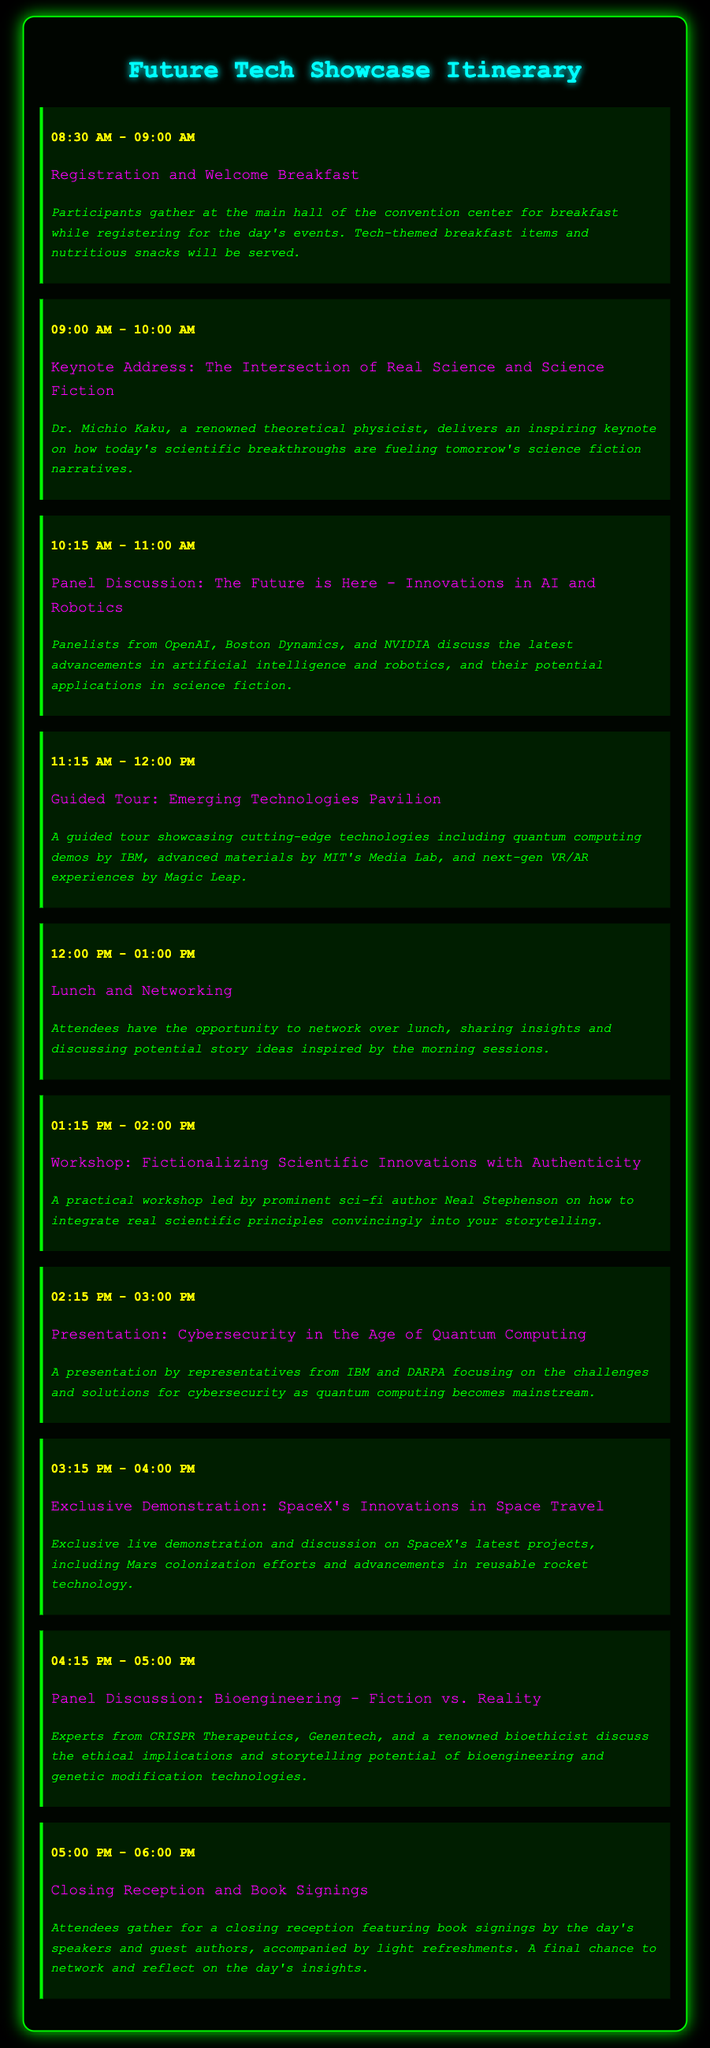What time does the registration start? The registration and welcome breakfast event starts at 08:30 AM.
Answer: 08:30 AM Who is delivering the keynote address? The keynote address is delivered by Dr. Michio Kaku, a renowned theoretical physicist.
Answer: Dr. Michio Kaku What is the main topic of the workshop at 01:15 PM? The workshop focuses on fictionalizing scientific innovations with authenticity.
Answer: Fictionalizing Scientific Innovations with Authenticity Which company is mentioned in conjunction with quantum computing challenges? The presentation mentions representatives from IBM and DARPA focusing on challenges in cybersecurity related to quantum computing.
Answer: IBM How long is the closing reception scheduled for? The closing reception is scheduled for one hour, from 05:00 PM to 06:00 PM.
Answer: One hour What type of demonstration takes place at 03:15 PM? An exclusive live demonstration of SpaceX's innovations in space travel occurs at this time.
Answer: Exclusive live demonstration What food is being served at the welcome breakfast? The event features tech-themed breakfast items and nutritious snacks.
Answer: Tech-themed breakfast items Which author's workshop is included in the schedule? The workshop is led by prominent sci-fi author Neal Stephenson.
Answer: Neal Stephenson What is discussed in the panel about bioengineering? Experts discuss the ethical implications and storytelling potential of bioengineering and genetic modification technologies.
Answer: Ethical implications and storytelling potential What happens during the lunch hour? Attendees have the opportunity to network over lunch and share insights.
Answer: Network over lunch 